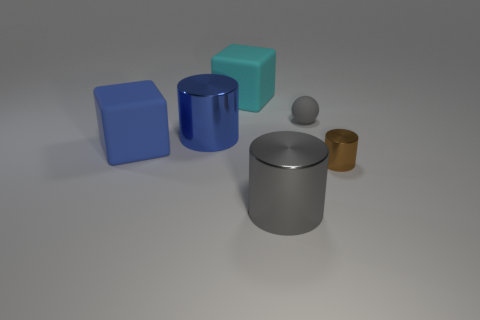Subtract all big metallic cylinders. How many cylinders are left? 1 Add 1 large metal things. How many objects exist? 7 Subtract all blocks. How many objects are left? 4 Subtract all brown metallic cylinders. Subtract all large gray cylinders. How many objects are left? 4 Add 1 large gray metal cylinders. How many large gray metal cylinders are left? 2 Add 6 big cyan cubes. How many big cyan cubes exist? 7 Subtract 0 red cubes. How many objects are left? 6 